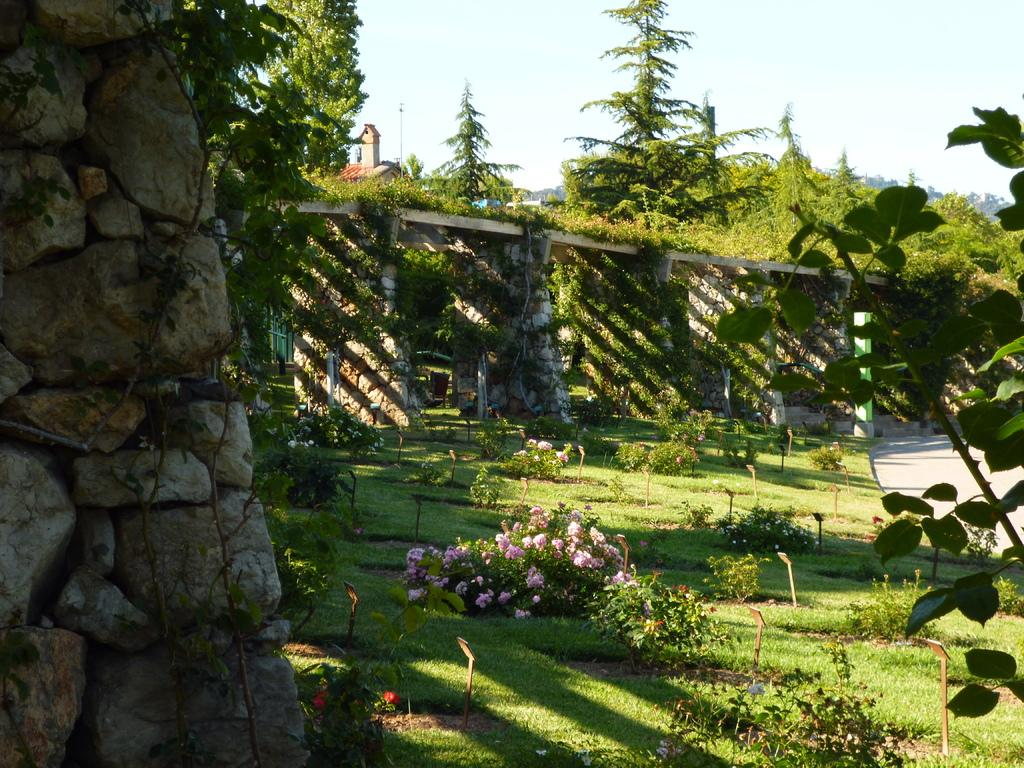What type of vegetation can be seen in the image? There is a group of plants and a group of trees in the image. What are the plants in the image holding? The plants in the image have flowers. What type of material are the stands in the image made of? The stands in the image are made of metal. What is the texture of the walls in the image? The walls in the image have stones. What structure is present in the image? There is a building in the image. What is the tall, thin object in the image? There is a pole in the image. What is visible in the sky in the image? The sky is visible in the image, and it looks cloudy. What type of cream can be seen on the monkey's fur in the image? There is no monkey present in the image, and therefore no cream on its fur. 